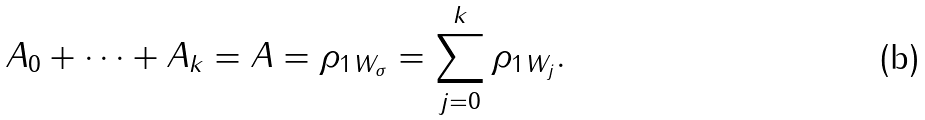Convert formula to latex. <formula><loc_0><loc_0><loc_500><loc_500>A _ { 0 } + \cdots + A _ { k } = A = \| \rho _ { 1 } \| _ { W _ { \sigma } } = \sum _ { j = 0 } ^ { k } \| \rho _ { 1 } \| _ { W _ { j } } .</formula> 